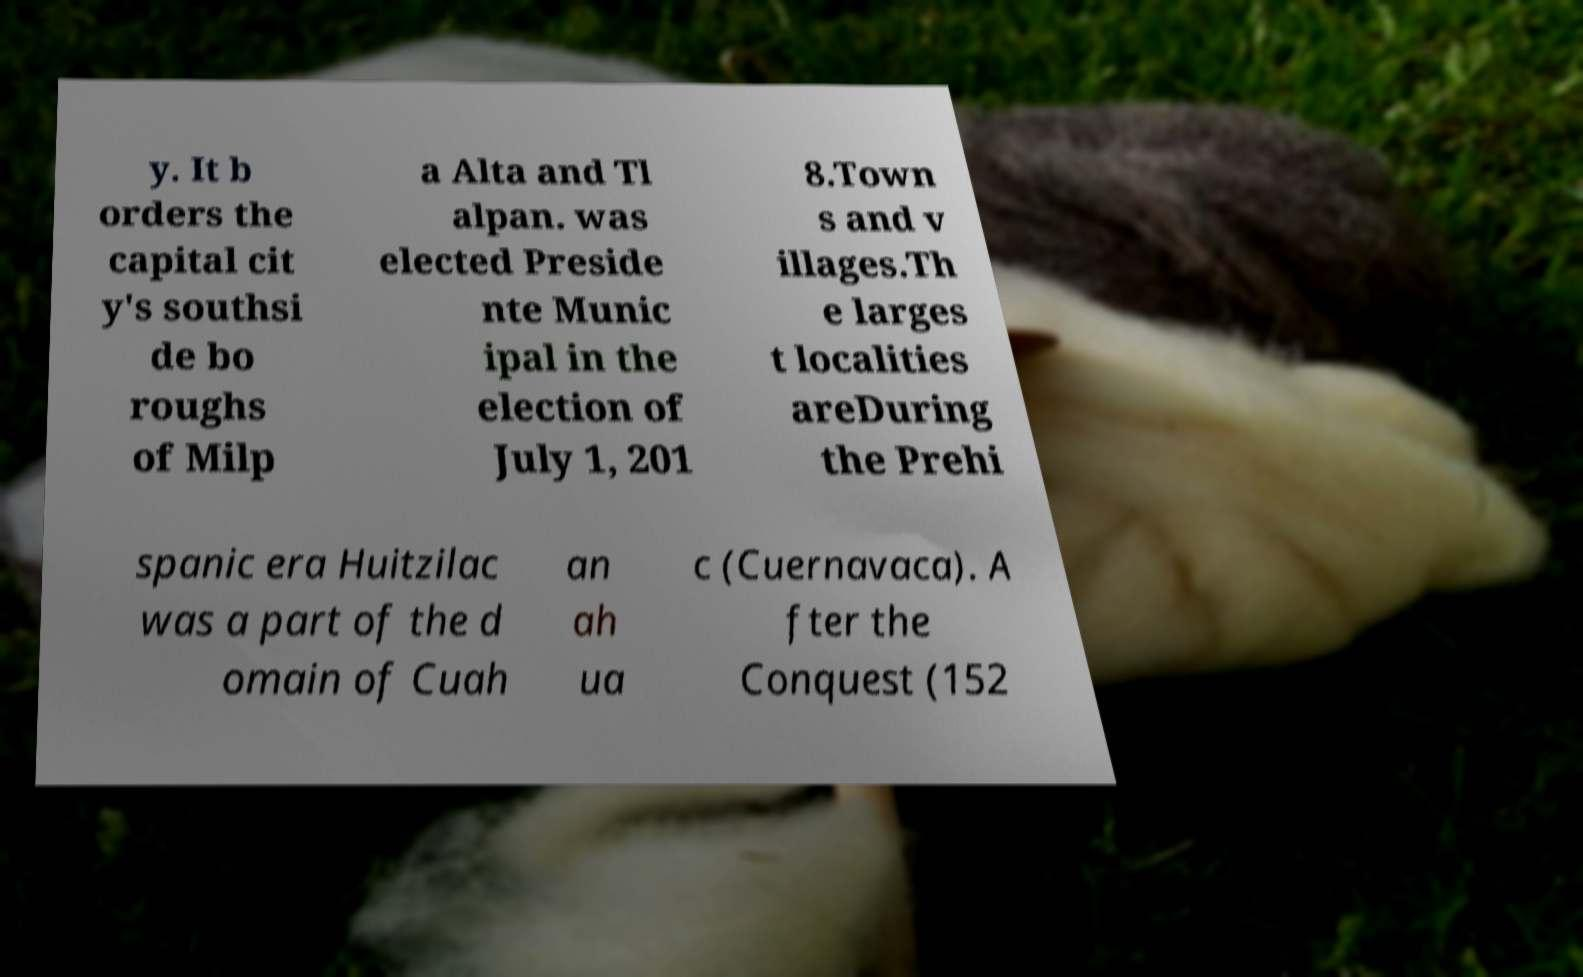Could you extract and type out the text from this image? y. It b orders the capital cit y's southsi de bo roughs of Milp a Alta and Tl alpan. was elected Preside nte Munic ipal in the election of July 1, 201 8.Town s and v illages.Th e larges t localities areDuring the Prehi spanic era Huitzilac was a part of the d omain of Cuah an ah ua c (Cuernavaca). A fter the Conquest (152 